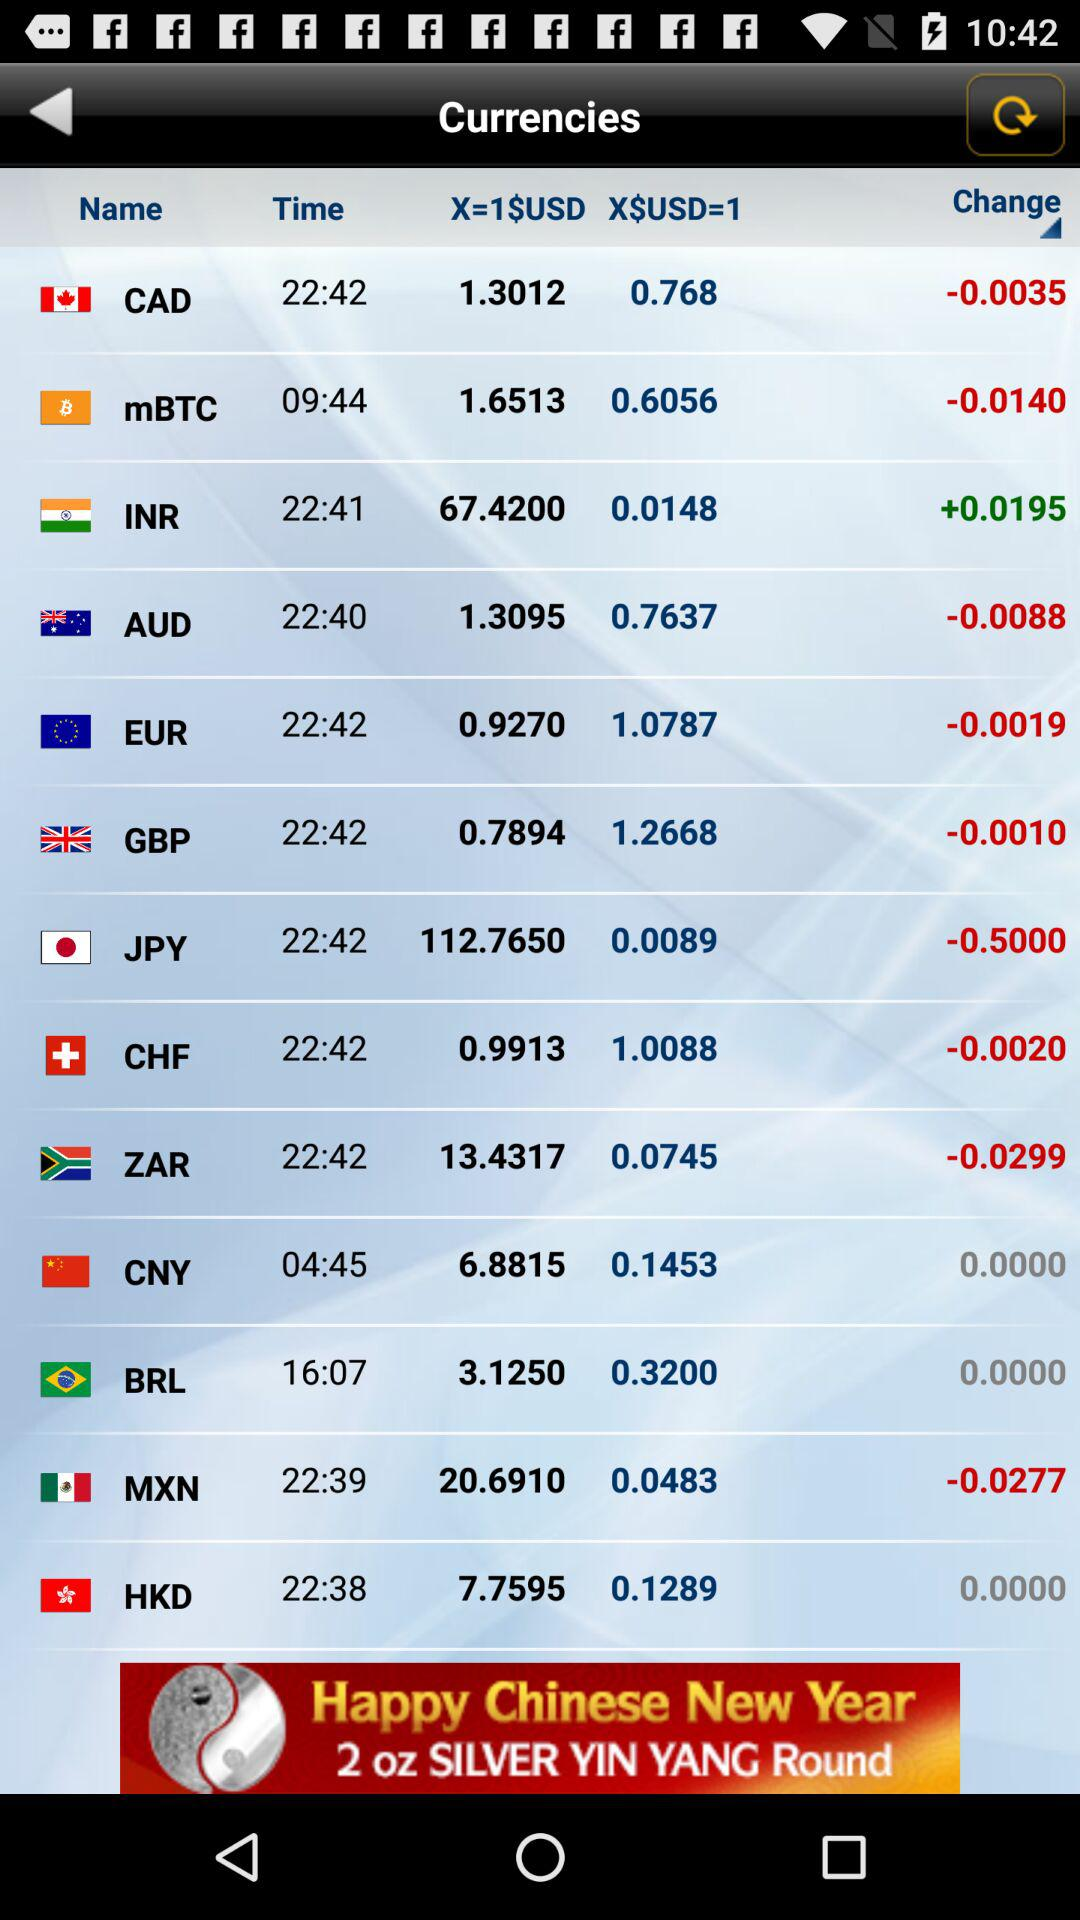How much USD changes in GBP? The change is -0.0010. 